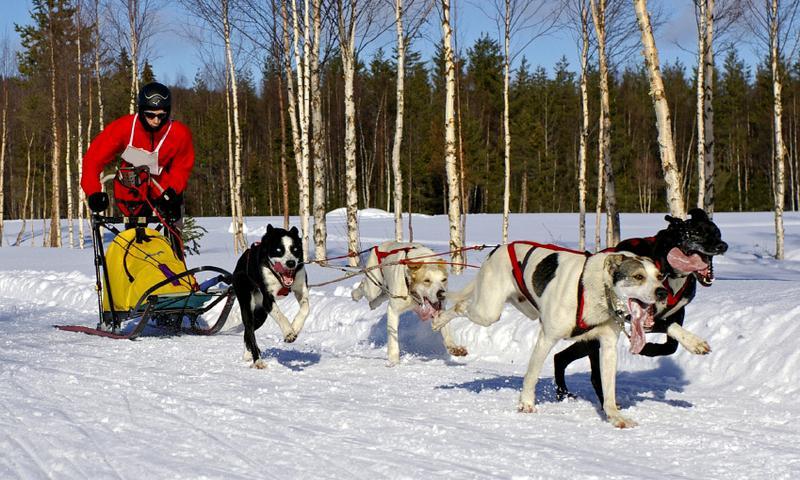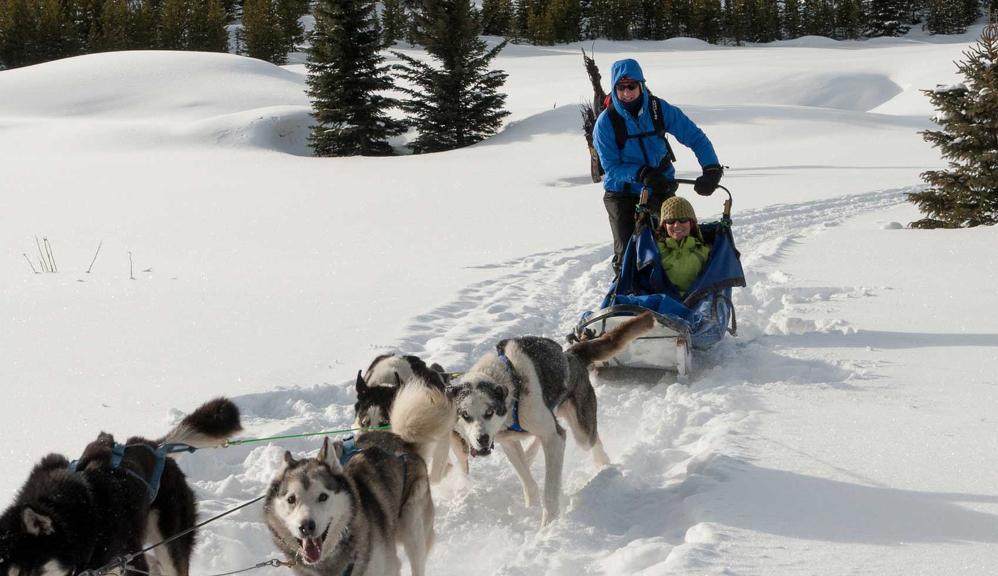The first image is the image on the left, the second image is the image on the right. Assess this claim about the two images: "The dogs are to the right of the sled in both pictures.". Correct or not? Answer yes or no. No. 